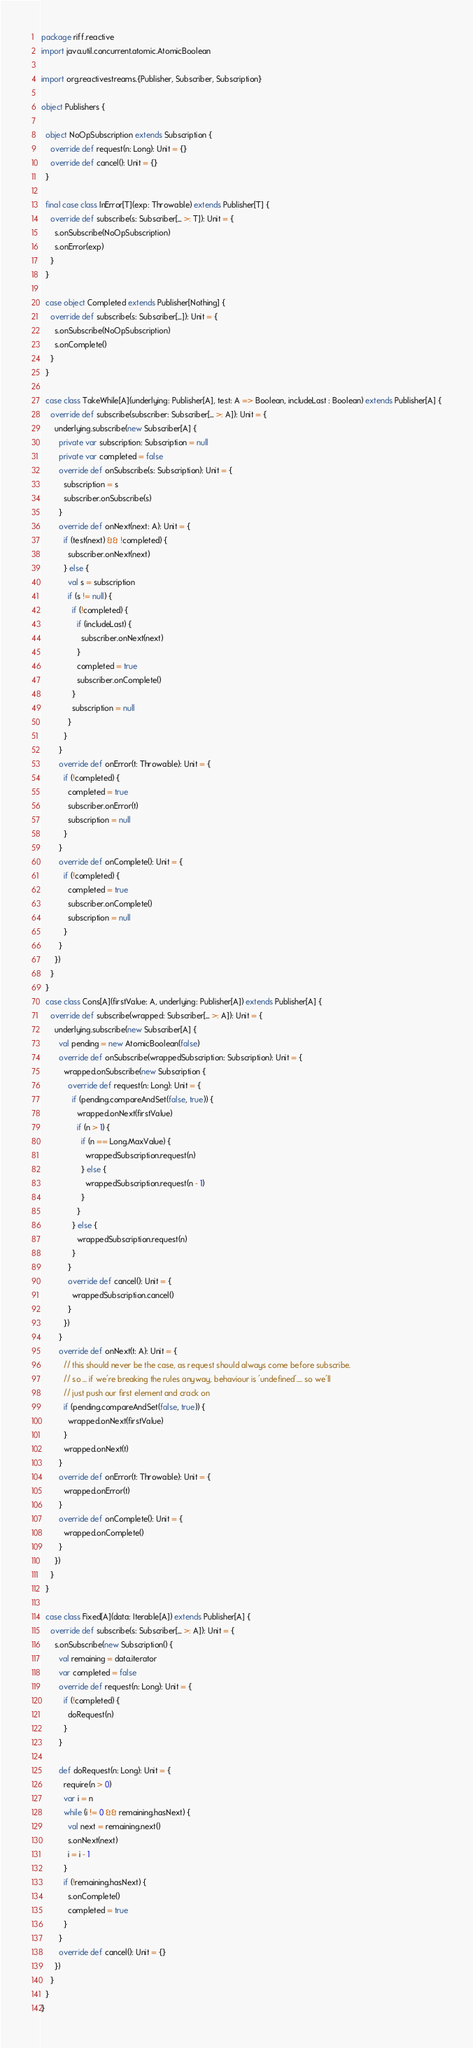Convert code to text. <code><loc_0><loc_0><loc_500><loc_500><_Scala_>package riff.reactive
import java.util.concurrent.atomic.AtomicBoolean

import org.reactivestreams.{Publisher, Subscriber, Subscription}

object Publishers {

  object NoOpSubscription extends Subscription {
    override def request(n: Long): Unit = {}
    override def cancel(): Unit = {}
  }

  final case class InError[T](exp: Throwable) extends Publisher[T] {
    override def subscribe(s: Subscriber[_ >: T]): Unit = {
      s.onSubscribe(NoOpSubscription)
      s.onError(exp)
    }
  }

  case object Completed extends Publisher[Nothing] {
    override def subscribe(s: Subscriber[_]): Unit = {
      s.onSubscribe(NoOpSubscription)
      s.onComplete()
    }
  }

  case class TakeWhile[A](underlying: Publisher[A], test: A => Boolean, includeLast : Boolean) extends Publisher[A] {
    override def subscribe(subscriber: Subscriber[_ >: A]): Unit = {
      underlying.subscribe(new Subscriber[A] {
        private var subscription: Subscription = null
        private var completed = false
        override def onSubscribe(s: Subscription): Unit = {
          subscription = s
          subscriber.onSubscribe(s)
        }
        override def onNext(next: A): Unit = {
          if (test(next) && !completed) {
            subscriber.onNext(next)
          } else {
            val s = subscription
            if (s != null) {
              if (!completed) {
                if (includeLast) {
                  subscriber.onNext(next)
                }
                completed = true
                subscriber.onComplete()
              }
              subscription = null
            }
          }
        }
        override def onError(t: Throwable): Unit = {
          if (!completed) {
            completed = true
            subscriber.onError(t)
            subscription = null
          }
        }
        override def onComplete(): Unit = {
          if (!completed) {
            completed = true
            subscriber.onComplete()
            subscription = null
          }
        }
      })
    }
  }
  case class Cons[A](firstValue: A, underlying: Publisher[A]) extends Publisher[A] {
    override def subscribe(wrapped: Subscriber[_ >: A]): Unit = {
      underlying.subscribe(new Subscriber[A] {
        val pending = new AtomicBoolean(false)
        override def onSubscribe(wrappedSubscription: Subscription): Unit = {
          wrapped.onSubscribe(new Subscription {
            override def request(n: Long): Unit = {
              if (pending.compareAndSet(false, true)) {
                wrapped.onNext(firstValue)
                if (n > 1) {
                  if (n == Long.MaxValue) {
                    wrappedSubscription.request(n)
                  } else {
                    wrappedSubscription.request(n - 1)
                  }
                }
              } else {
                wrappedSubscription.request(n)
              }
            }
            override def cancel(): Unit = {
              wrappedSubscription.cancel()
            }
          })
        }
        override def onNext(t: A): Unit = {
          // this should never be the case, as request should always come before subscribe.
          // so ... if we're breaking the rules anyway, behaviour is 'undefined'.... so we'll
          // just push our first element and crack on
          if (pending.compareAndSet(false, true)) {
            wrapped.onNext(firstValue)
          }
          wrapped.onNext(t)
        }
        override def onError(t: Throwable): Unit = {
          wrapped.onError(t)
        }
        override def onComplete(): Unit = {
          wrapped.onComplete()
        }
      })
    }
  }

  case class Fixed[A](data: Iterable[A]) extends Publisher[A] {
    override def subscribe(s: Subscriber[_ >: A]): Unit = {
      s.onSubscribe(new Subscription() {
        val remaining = data.iterator
        var completed = false
        override def request(n: Long): Unit = {
          if (!completed) {
            doRequest(n)
          }
        }

        def doRequest(n: Long): Unit = {
          require(n > 0)
          var i = n
          while (i != 0 && remaining.hasNext) {
            val next = remaining.next()
            s.onNext(next)
            i = i - 1
          }
          if (!remaining.hasNext) {
            s.onComplete()
            completed = true
          }
        }
        override def cancel(): Unit = {}
      })
    }
  }
}
</code> 